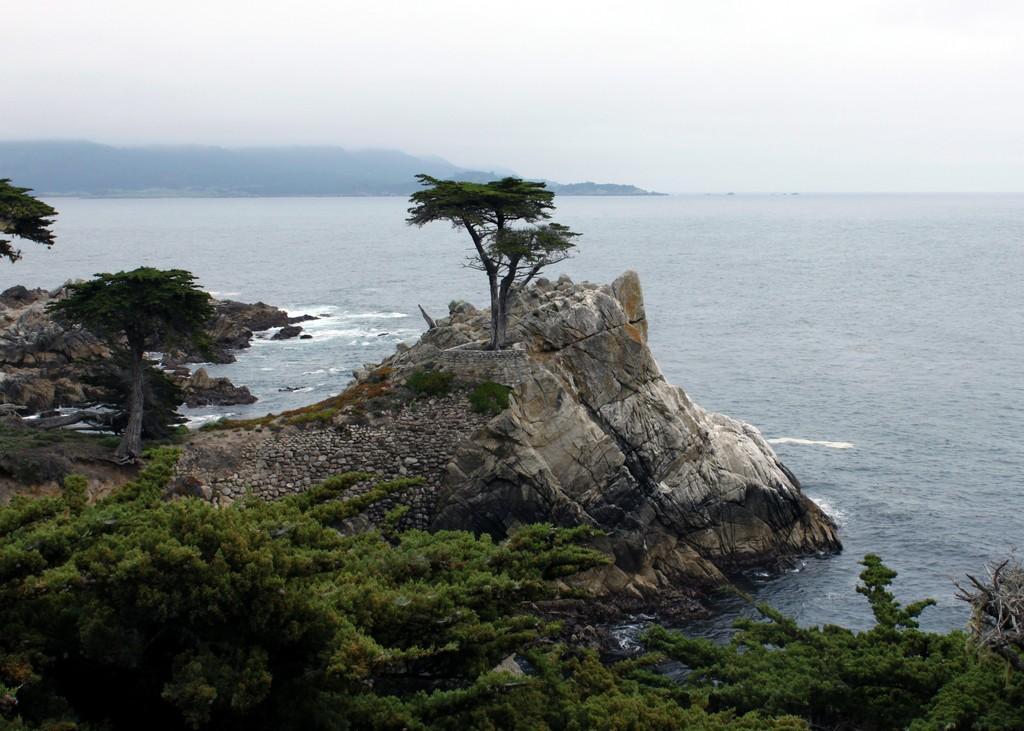Can you describe this image briefly? As we can see in the image there are trees, water and hills. On the top there is sky. 